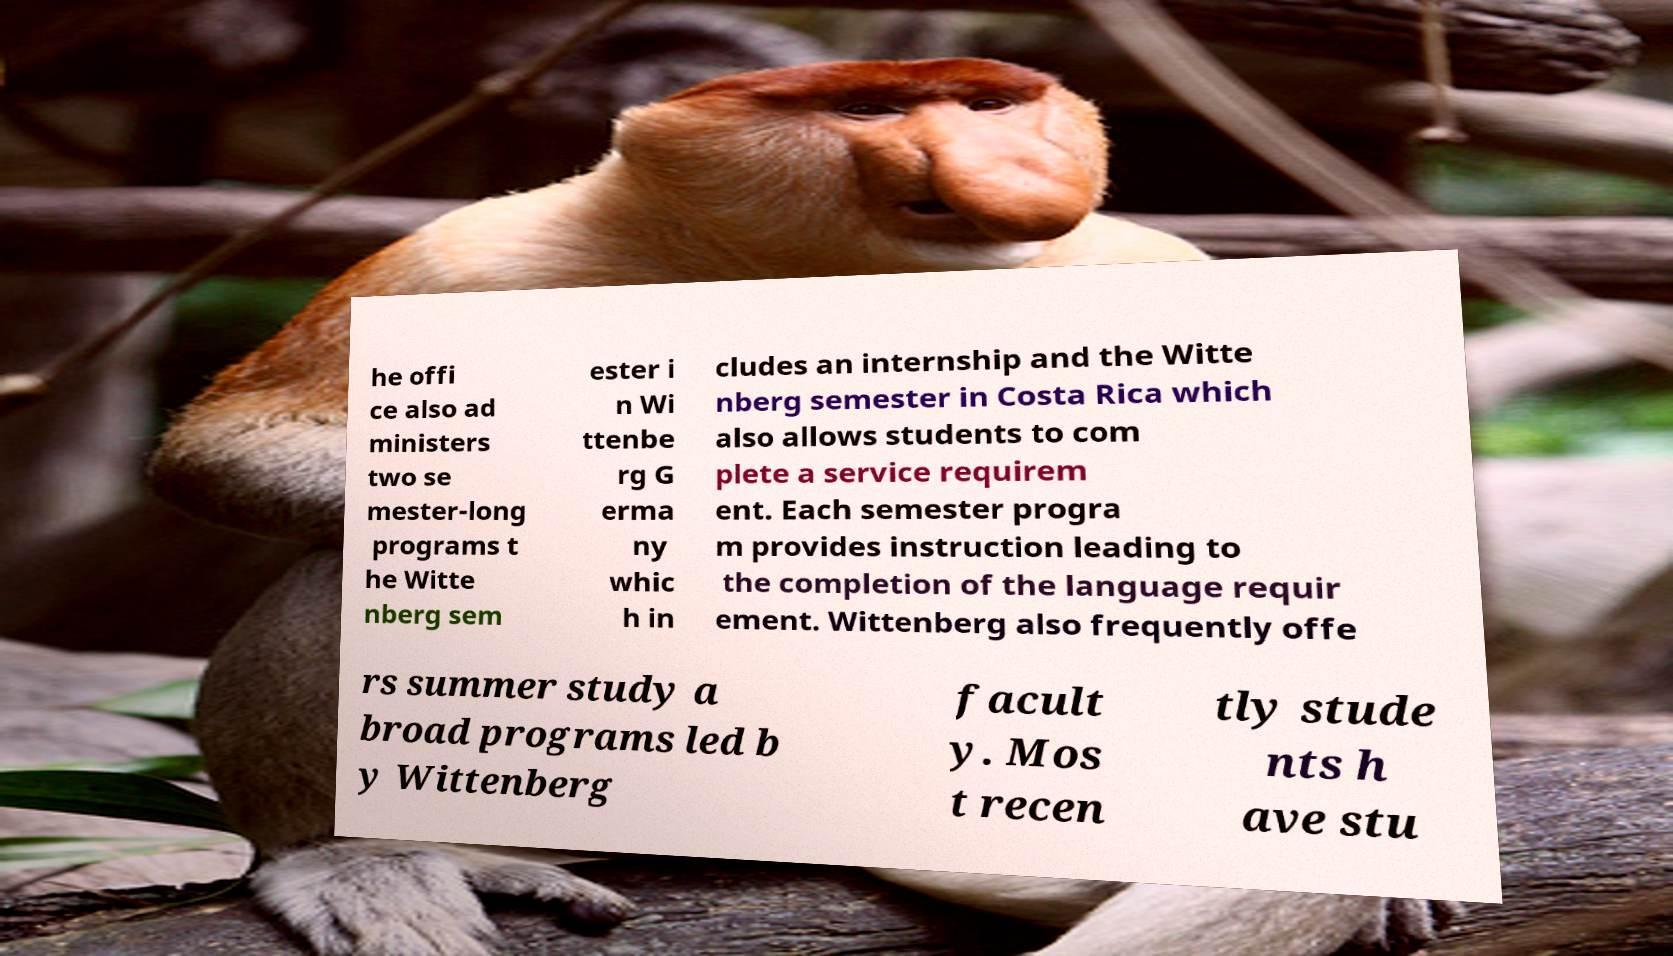Can you accurately transcribe the text from the provided image for me? he offi ce also ad ministers two se mester-long programs t he Witte nberg sem ester i n Wi ttenbe rg G erma ny whic h in cludes an internship and the Witte nberg semester in Costa Rica which also allows students to com plete a service requirem ent. Each semester progra m provides instruction leading to the completion of the language requir ement. Wittenberg also frequently offe rs summer study a broad programs led b y Wittenberg facult y. Mos t recen tly stude nts h ave stu 